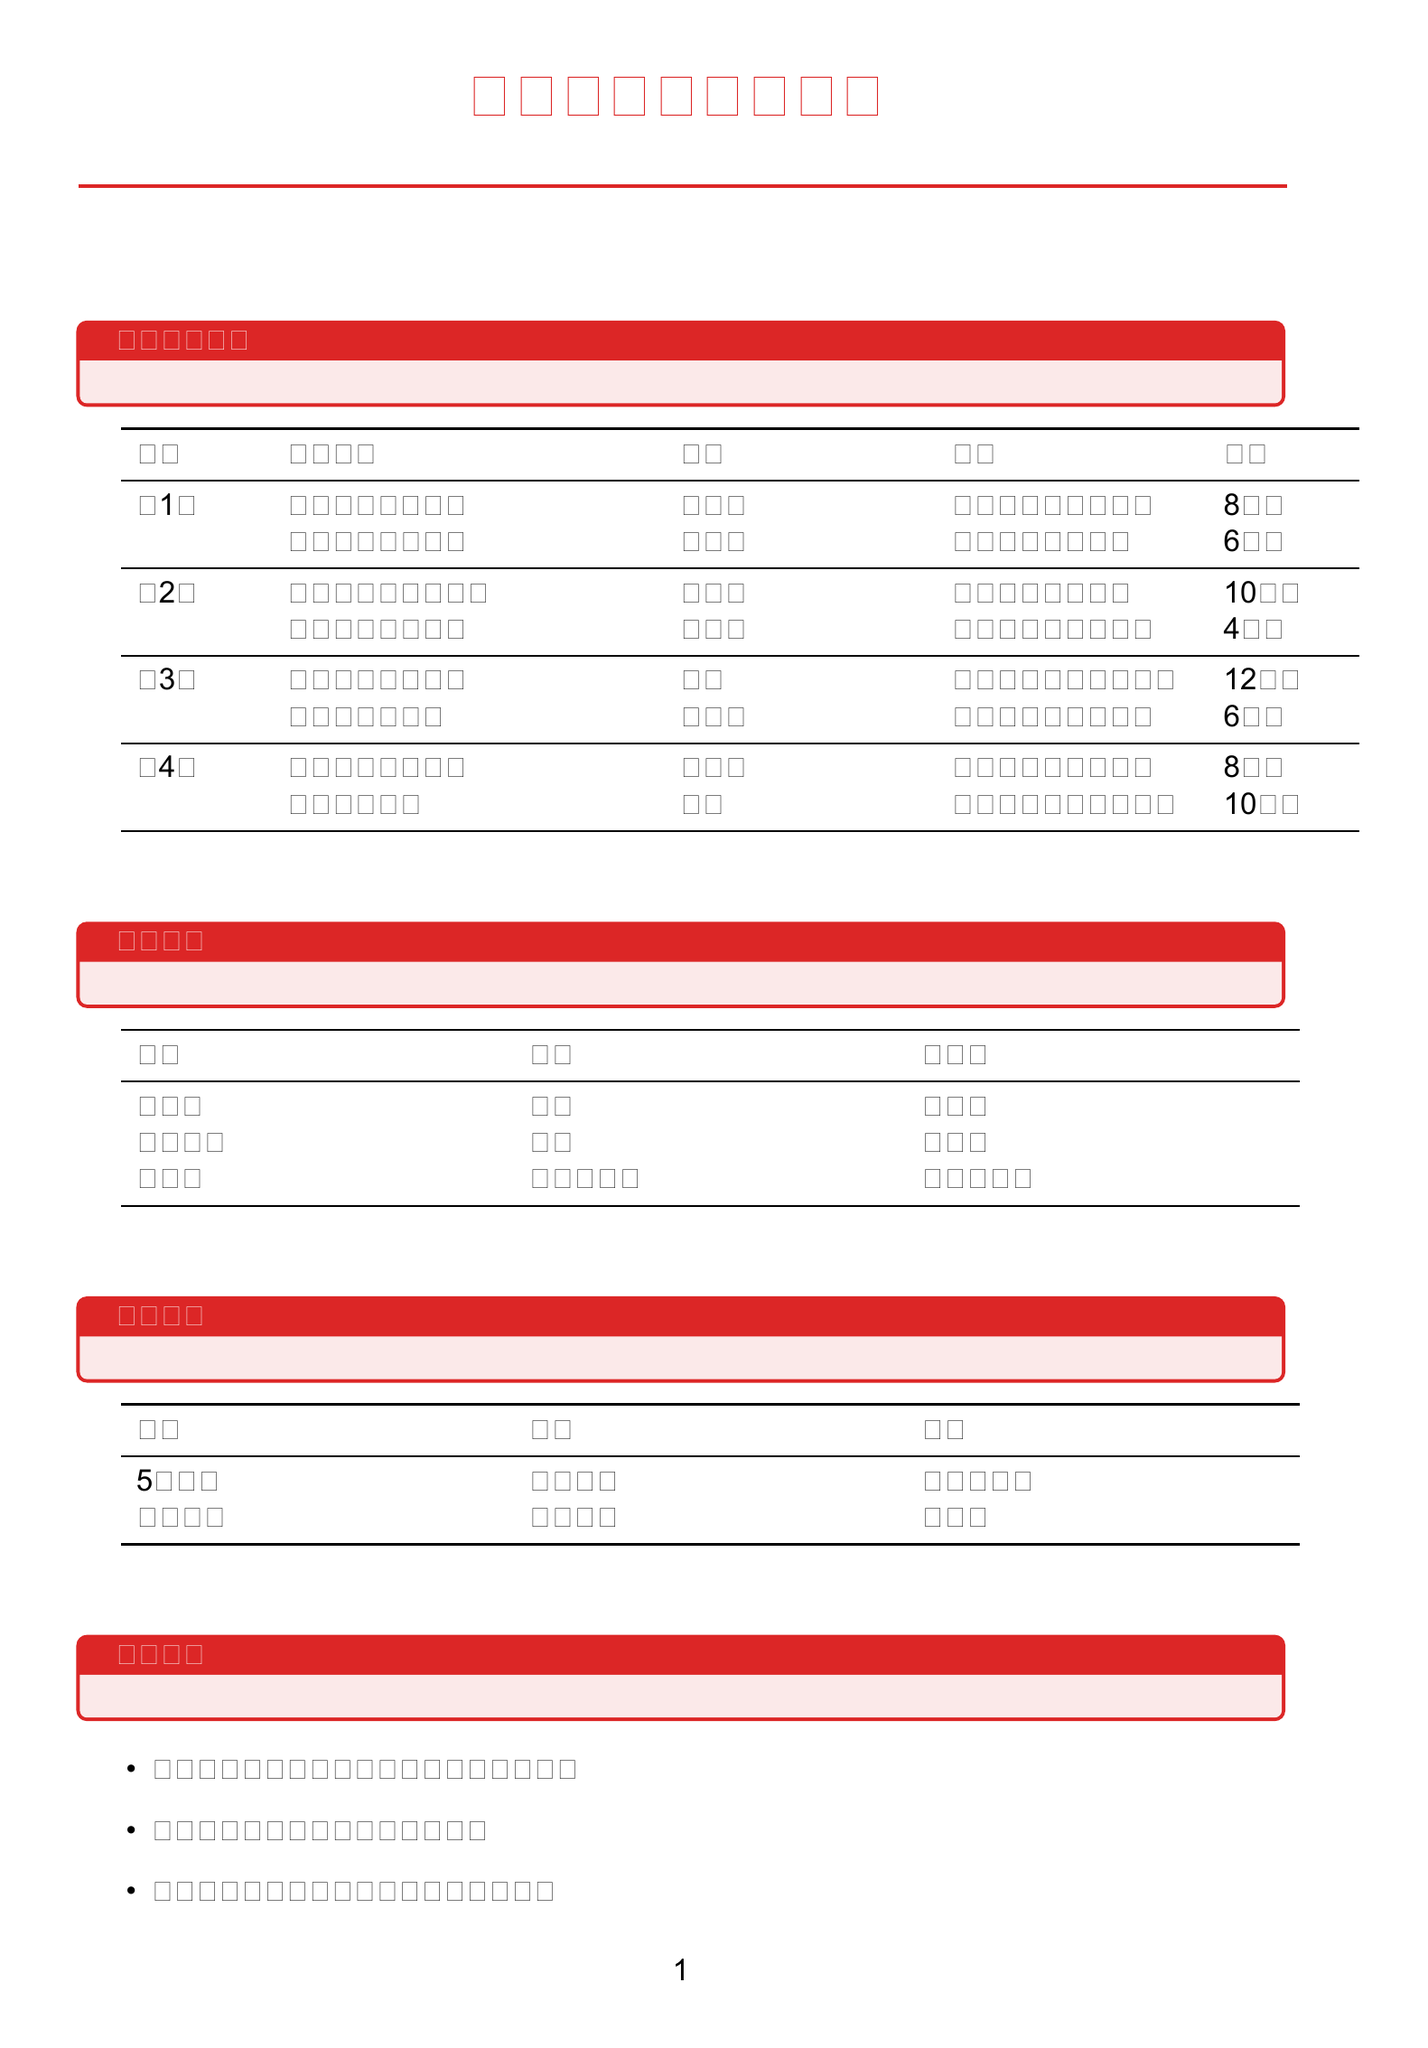What is the duration of "高层建筑灭火战术"? The duration is explicitly stated in the document as 8小时.
Answer: 8小时 Who is the instructor for "危险化学品事故处置"? The document lists the instructor as 张建国.
Answer: 张建国 In which location is the "消防泵操作与维护" course held? The location for this course is mentioned as 天津市消防装备库.
Answer: 天津市消防装备库 How many hours is the "水域救援技能" course? The document provides the duration of this course as 10小时.
Answer: 10小时 Which group is responsible for maintaining the "消防水带"? The document indicates that the maintenance is the responsibility of 器材组.
Answer: 器材组 What is the frequency of the "5公里跑" activity? The frequency is noted in the document as 每周两次.
Answer: 每周两次 Which week features "地铁火灾救援演练"? The document states this course is scheduled in 第3周.
Answer: 第3周 How often is a large joint rescue drill organized? According to the document, it is organized 每季度.
Answer: 每季度 What is the total number of courses listed for week 2? The document shows that there are 2 courses listed for week 2.
Answer: 2 